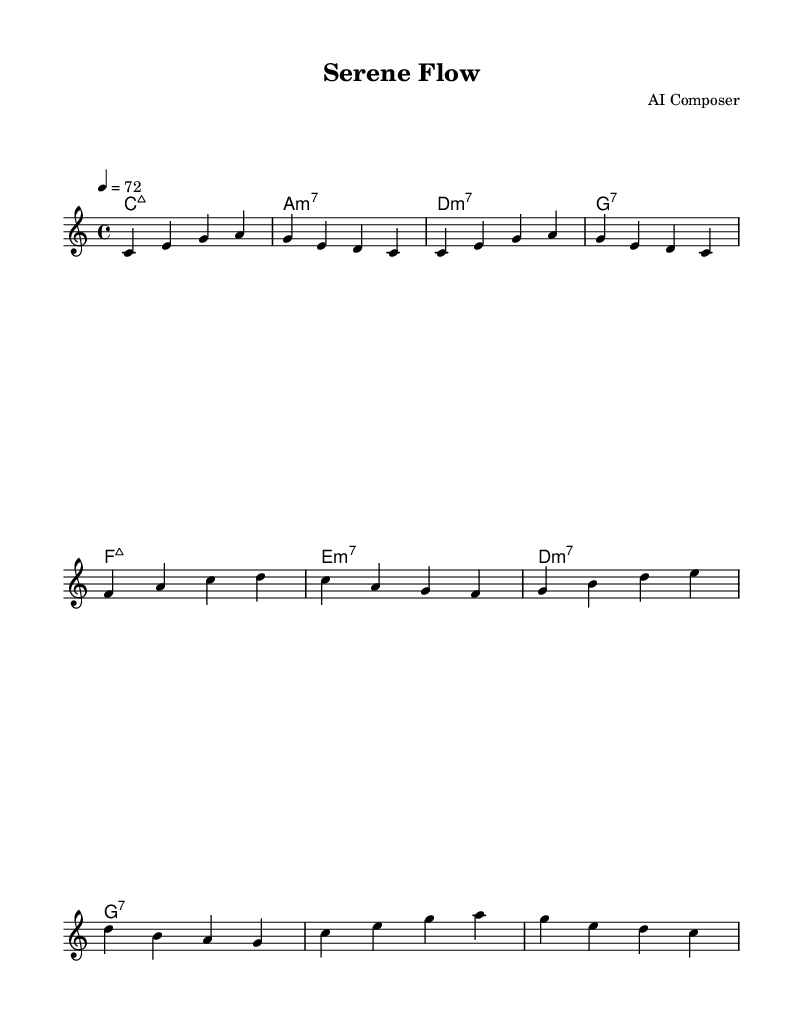What is the key signature of this music? The key signature is C major, which has no sharps or flats.
Answer: C major What is the time signature of this music? The time signature indicated in the sheet music is 4/4, meaning there are four beats in a measure and the quarter note gets one beat.
Answer: 4/4 What is the tempo marked in the music? The tempo is marked as 4 equals 72, indicating that there are 72 beats per minute.
Answer: 72 How many measures are there in section A? Section A consists of four measures based on the melody provided above.
Answer: 4 Which chord changes appear at the beginning of the music? The chord changes at the beginning are C major 7, A minor 7, D minor 7, and G dominant 7, which create a smooth harmonic foundation.
Answer: C major 7, A minor 7, D minor 7, G7 What is the melodic interval between the first two notes in the melody? The first two notes are C and E, which are a major third apart. A major third spans four half steps.
Answer: Major third What kind of musical piece is "Serene Flow"? "Serene Flow" is characterized as a smooth jazz instrumental, designed to facilitate work and concentration.
Answer: Smooth jazz instrumental 